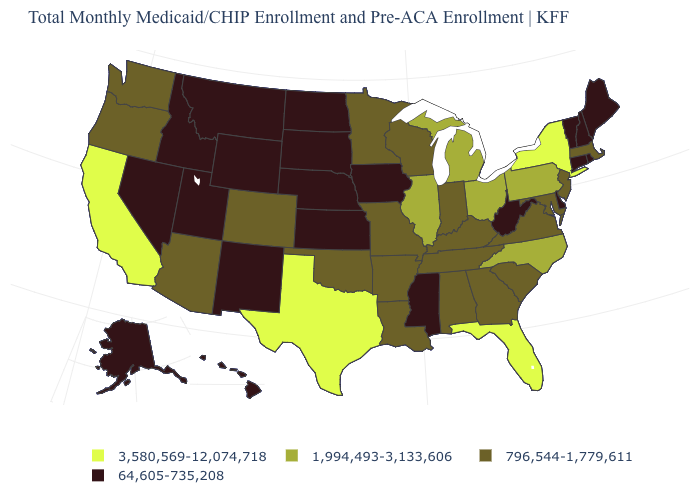Name the states that have a value in the range 796,544-1,779,611?
Answer briefly. Alabama, Arizona, Arkansas, Colorado, Georgia, Indiana, Kentucky, Louisiana, Maryland, Massachusetts, Minnesota, Missouri, New Jersey, Oklahoma, Oregon, South Carolina, Tennessee, Virginia, Washington, Wisconsin. Does the first symbol in the legend represent the smallest category?
Give a very brief answer. No. What is the value of New Hampshire?
Quick response, please. 64,605-735,208. Which states hav the highest value in the Northeast?
Give a very brief answer. New York. What is the highest value in the MidWest ?
Concise answer only. 1,994,493-3,133,606. Does California have the highest value in the West?
Give a very brief answer. Yes. Is the legend a continuous bar?
Give a very brief answer. No. What is the lowest value in states that border South Dakota?
Short answer required. 64,605-735,208. Name the states that have a value in the range 3,580,569-12,074,718?
Quick response, please. California, Florida, New York, Texas. Does Rhode Island have the same value as Colorado?
Short answer required. No. What is the value of Michigan?
Give a very brief answer. 1,994,493-3,133,606. What is the value of Tennessee?
Be succinct. 796,544-1,779,611. Does Maryland have the highest value in the South?
Concise answer only. No. Name the states that have a value in the range 1,994,493-3,133,606?
Quick response, please. Illinois, Michigan, North Carolina, Ohio, Pennsylvania. 